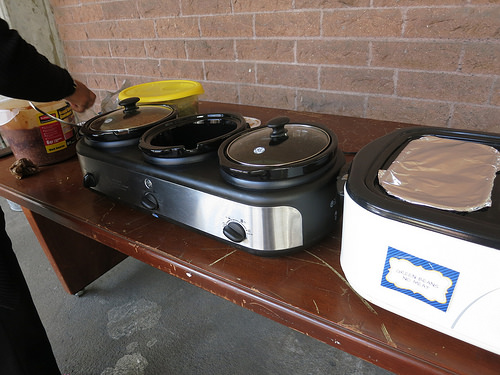<image>
Is there a sign to the right of the lid? Yes. From this viewpoint, the sign is positioned to the right side relative to the lid. 